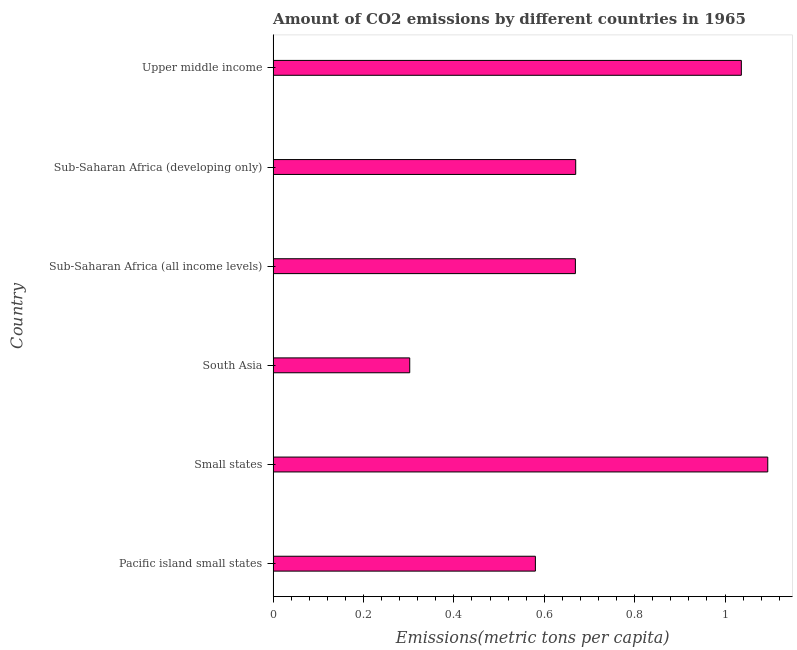Does the graph contain any zero values?
Ensure brevity in your answer.  No. Does the graph contain grids?
Provide a short and direct response. No. What is the title of the graph?
Keep it short and to the point. Amount of CO2 emissions by different countries in 1965. What is the label or title of the X-axis?
Give a very brief answer. Emissions(metric tons per capita). What is the label or title of the Y-axis?
Give a very brief answer. Country. What is the amount of co2 emissions in Sub-Saharan Africa (all income levels)?
Your response must be concise. 0.67. Across all countries, what is the maximum amount of co2 emissions?
Offer a terse response. 1.09. Across all countries, what is the minimum amount of co2 emissions?
Make the answer very short. 0.3. In which country was the amount of co2 emissions maximum?
Your response must be concise. Small states. What is the sum of the amount of co2 emissions?
Your answer should be compact. 4.35. What is the difference between the amount of co2 emissions in South Asia and Upper middle income?
Provide a short and direct response. -0.73. What is the average amount of co2 emissions per country?
Provide a succinct answer. 0.72. What is the median amount of co2 emissions?
Your response must be concise. 0.67. What is the ratio of the amount of co2 emissions in Pacific island small states to that in Upper middle income?
Make the answer very short. 0.56. Is the amount of co2 emissions in South Asia less than that in Upper middle income?
Offer a terse response. Yes. What is the difference between the highest and the second highest amount of co2 emissions?
Provide a succinct answer. 0.06. What is the difference between the highest and the lowest amount of co2 emissions?
Your answer should be very brief. 0.79. How many bars are there?
Provide a succinct answer. 6. How many countries are there in the graph?
Offer a terse response. 6. What is the Emissions(metric tons per capita) in Pacific island small states?
Make the answer very short. 0.58. What is the Emissions(metric tons per capita) of Small states?
Your answer should be very brief. 1.09. What is the Emissions(metric tons per capita) of South Asia?
Make the answer very short. 0.3. What is the Emissions(metric tons per capita) in Sub-Saharan Africa (all income levels)?
Your response must be concise. 0.67. What is the Emissions(metric tons per capita) of Sub-Saharan Africa (developing only)?
Give a very brief answer. 0.67. What is the Emissions(metric tons per capita) of Upper middle income?
Make the answer very short. 1.04. What is the difference between the Emissions(metric tons per capita) in Pacific island small states and Small states?
Give a very brief answer. -0.51. What is the difference between the Emissions(metric tons per capita) in Pacific island small states and South Asia?
Your answer should be compact. 0.28. What is the difference between the Emissions(metric tons per capita) in Pacific island small states and Sub-Saharan Africa (all income levels)?
Give a very brief answer. -0.09. What is the difference between the Emissions(metric tons per capita) in Pacific island small states and Sub-Saharan Africa (developing only)?
Make the answer very short. -0.09. What is the difference between the Emissions(metric tons per capita) in Pacific island small states and Upper middle income?
Your answer should be compact. -0.46. What is the difference between the Emissions(metric tons per capita) in Small states and South Asia?
Provide a short and direct response. 0.79. What is the difference between the Emissions(metric tons per capita) in Small states and Sub-Saharan Africa (all income levels)?
Your response must be concise. 0.43. What is the difference between the Emissions(metric tons per capita) in Small states and Sub-Saharan Africa (developing only)?
Provide a succinct answer. 0.42. What is the difference between the Emissions(metric tons per capita) in Small states and Upper middle income?
Keep it short and to the point. 0.06. What is the difference between the Emissions(metric tons per capita) in South Asia and Sub-Saharan Africa (all income levels)?
Ensure brevity in your answer.  -0.37. What is the difference between the Emissions(metric tons per capita) in South Asia and Sub-Saharan Africa (developing only)?
Make the answer very short. -0.37. What is the difference between the Emissions(metric tons per capita) in South Asia and Upper middle income?
Your answer should be compact. -0.73. What is the difference between the Emissions(metric tons per capita) in Sub-Saharan Africa (all income levels) and Sub-Saharan Africa (developing only)?
Offer a terse response. -0. What is the difference between the Emissions(metric tons per capita) in Sub-Saharan Africa (all income levels) and Upper middle income?
Offer a very short reply. -0.37. What is the difference between the Emissions(metric tons per capita) in Sub-Saharan Africa (developing only) and Upper middle income?
Ensure brevity in your answer.  -0.37. What is the ratio of the Emissions(metric tons per capita) in Pacific island small states to that in Small states?
Offer a very short reply. 0.53. What is the ratio of the Emissions(metric tons per capita) in Pacific island small states to that in South Asia?
Offer a very short reply. 1.92. What is the ratio of the Emissions(metric tons per capita) in Pacific island small states to that in Sub-Saharan Africa (all income levels)?
Make the answer very short. 0.87. What is the ratio of the Emissions(metric tons per capita) in Pacific island small states to that in Sub-Saharan Africa (developing only)?
Provide a short and direct response. 0.87. What is the ratio of the Emissions(metric tons per capita) in Pacific island small states to that in Upper middle income?
Your answer should be very brief. 0.56. What is the ratio of the Emissions(metric tons per capita) in Small states to that in South Asia?
Your response must be concise. 3.62. What is the ratio of the Emissions(metric tons per capita) in Small states to that in Sub-Saharan Africa (all income levels)?
Offer a very short reply. 1.64. What is the ratio of the Emissions(metric tons per capita) in Small states to that in Sub-Saharan Africa (developing only)?
Keep it short and to the point. 1.64. What is the ratio of the Emissions(metric tons per capita) in Small states to that in Upper middle income?
Make the answer very short. 1.06. What is the ratio of the Emissions(metric tons per capita) in South Asia to that in Sub-Saharan Africa (all income levels)?
Make the answer very short. 0.45. What is the ratio of the Emissions(metric tons per capita) in South Asia to that in Sub-Saharan Africa (developing only)?
Offer a very short reply. 0.45. What is the ratio of the Emissions(metric tons per capita) in South Asia to that in Upper middle income?
Provide a succinct answer. 0.29. What is the ratio of the Emissions(metric tons per capita) in Sub-Saharan Africa (all income levels) to that in Sub-Saharan Africa (developing only)?
Make the answer very short. 1. What is the ratio of the Emissions(metric tons per capita) in Sub-Saharan Africa (all income levels) to that in Upper middle income?
Keep it short and to the point. 0.65. What is the ratio of the Emissions(metric tons per capita) in Sub-Saharan Africa (developing only) to that in Upper middle income?
Your response must be concise. 0.65. 